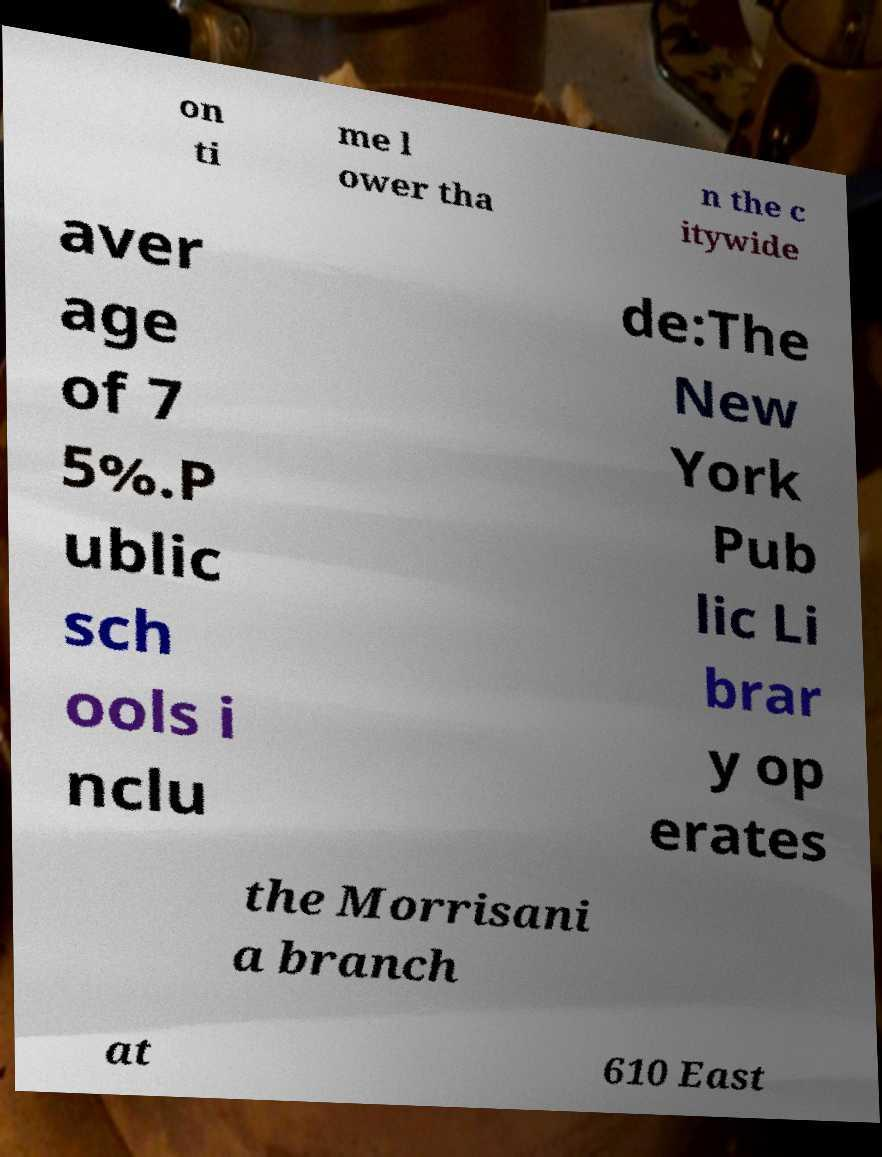Can you read and provide the text displayed in the image?This photo seems to have some interesting text. Can you extract and type it out for me? on ti me l ower tha n the c itywide aver age of 7 5%.P ublic sch ools i nclu de:The New York Pub lic Li brar y op erates the Morrisani a branch at 610 East 